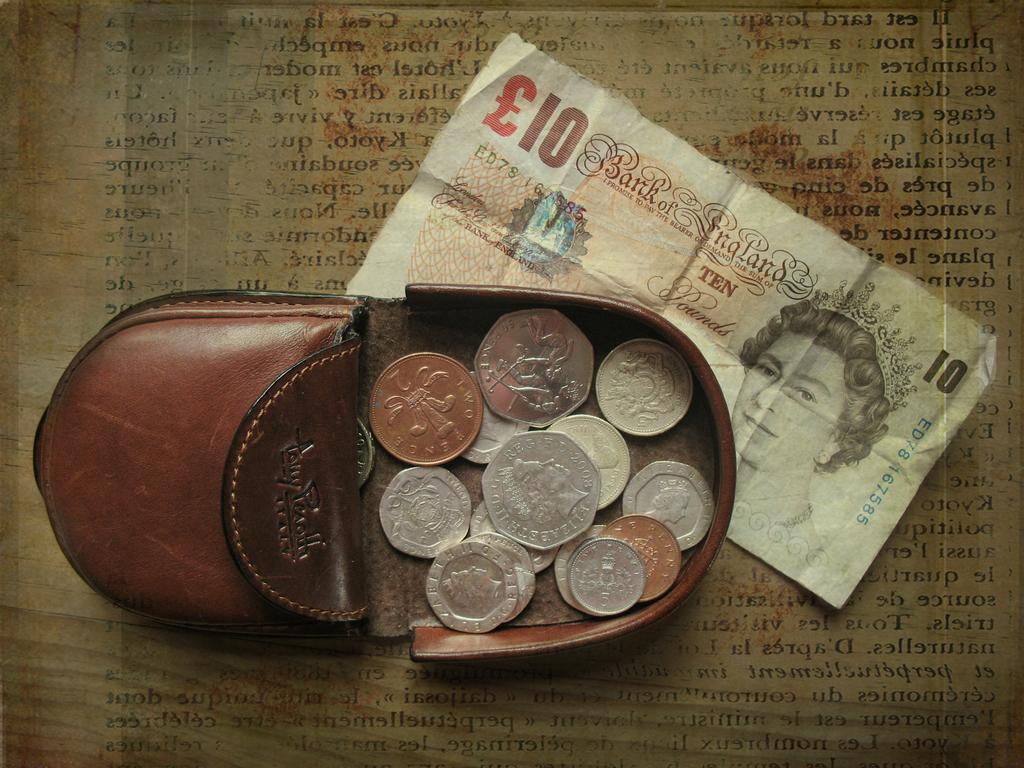<image>
Give a short and clear explanation of the subsequent image. a 10 Bank of England bill is under a coin purse 